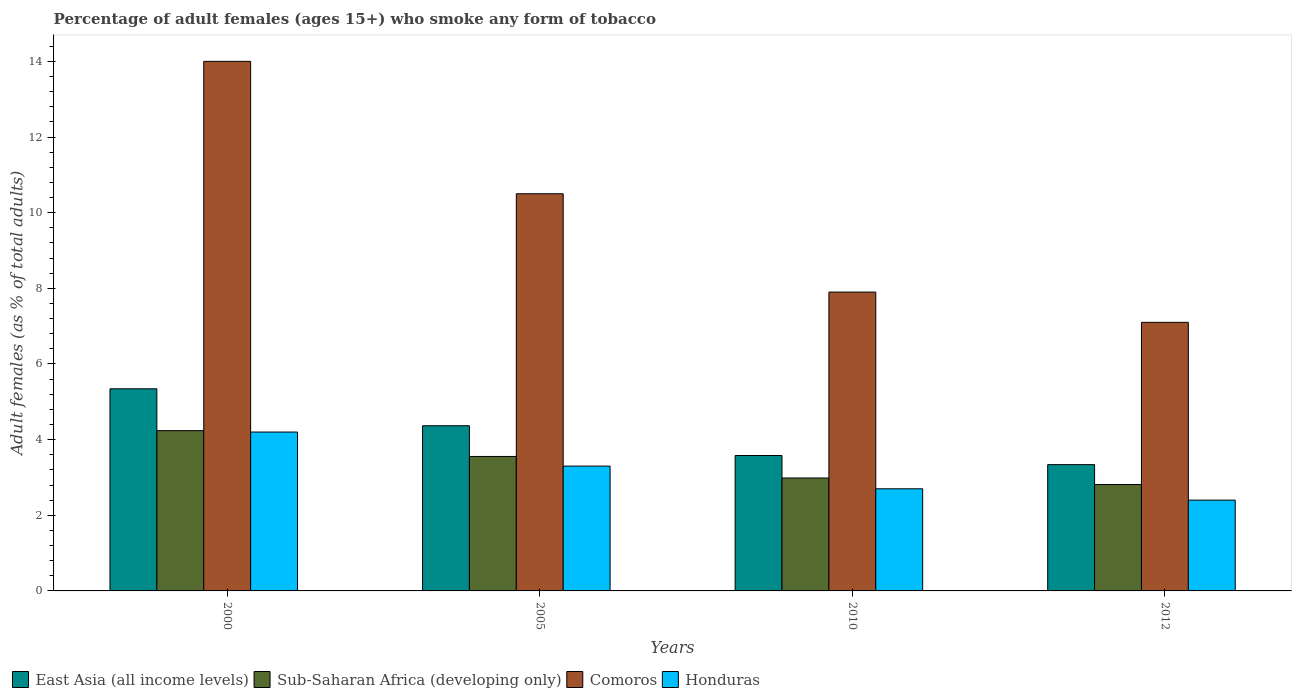How many groups of bars are there?
Your answer should be compact. 4. Are the number of bars per tick equal to the number of legend labels?
Make the answer very short. Yes. Are the number of bars on each tick of the X-axis equal?
Ensure brevity in your answer.  Yes. How many bars are there on the 3rd tick from the left?
Provide a short and direct response. 4. How many bars are there on the 3rd tick from the right?
Your answer should be very brief. 4. In how many cases, is the number of bars for a given year not equal to the number of legend labels?
Offer a terse response. 0. What is the percentage of adult females who smoke in Sub-Saharan Africa (developing only) in 2010?
Your response must be concise. 2.99. Across all years, what is the minimum percentage of adult females who smoke in Sub-Saharan Africa (developing only)?
Offer a terse response. 2.81. In which year was the percentage of adult females who smoke in East Asia (all income levels) maximum?
Provide a succinct answer. 2000. In which year was the percentage of adult females who smoke in East Asia (all income levels) minimum?
Give a very brief answer. 2012. What is the total percentage of adult females who smoke in Comoros in the graph?
Your answer should be compact. 39.5. What is the difference between the percentage of adult females who smoke in Sub-Saharan Africa (developing only) in 2000 and that in 2012?
Provide a short and direct response. 1.42. What is the difference between the percentage of adult females who smoke in Comoros in 2010 and the percentage of adult females who smoke in Honduras in 2012?
Give a very brief answer. 5.5. What is the average percentage of adult females who smoke in Sub-Saharan Africa (developing only) per year?
Offer a very short reply. 3.4. What is the ratio of the percentage of adult females who smoke in Sub-Saharan Africa (developing only) in 2005 to that in 2012?
Provide a short and direct response. 1.26. What is the difference between the highest and the second highest percentage of adult females who smoke in Sub-Saharan Africa (developing only)?
Provide a succinct answer. 0.68. What is the difference between the highest and the lowest percentage of adult females who smoke in Honduras?
Your answer should be very brief. 1.8. In how many years, is the percentage of adult females who smoke in East Asia (all income levels) greater than the average percentage of adult females who smoke in East Asia (all income levels) taken over all years?
Offer a very short reply. 2. Is it the case that in every year, the sum of the percentage of adult females who smoke in Sub-Saharan Africa (developing only) and percentage of adult females who smoke in East Asia (all income levels) is greater than the sum of percentage of adult females who smoke in Comoros and percentage of adult females who smoke in Honduras?
Your answer should be very brief. No. What does the 2nd bar from the left in 2005 represents?
Ensure brevity in your answer.  Sub-Saharan Africa (developing only). What does the 3rd bar from the right in 2012 represents?
Your answer should be compact. Sub-Saharan Africa (developing only). Is it the case that in every year, the sum of the percentage of adult females who smoke in Honduras and percentage of adult females who smoke in Sub-Saharan Africa (developing only) is greater than the percentage of adult females who smoke in Comoros?
Provide a succinct answer. No. How many bars are there?
Offer a terse response. 16. Are all the bars in the graph horizontal?
Offer a very short reply. No. What is the difference between two consecutive major ticks on the Y-axis?
Make the answer very short. 2. Where does the legend appear in the graph?
Offer a terse response. Bottom left. How many legend labels are there?
Your answer should be very brief. 4. What is the title of the graph?
Offer a very short reply. Percentage of adult females (ages 15+) who smoke any form of tobacco. What is the label or title of the Y-axis?
Your answer should be very brief. Adult females (as % of total adults). What is the Adult females (as % of total adults) of East Asia (all income levels) in 2000?
Offer a very short reply. 5.34. What is the Adult females (as % of total adults) in Sub-Saharan Africa (developing only) in 2000?
Make the answer very short. 4.24. What is the Adult females (as % of total adults) in Comoros in 2000?
Provide a short and direct response. 14. What is the Adult females (as % of total adults) in Honduras in 2000?
Ensure brevity in your answer.  4.2. What is the Adult females (as % of total adults) of East Asia (all income levels) in 2005?
Offer a terse response. 4.37. What is the Adult females (as % of total adults) of Sub-Saharan Africa (developing only) in 2005?
Your answer should be compact. 3.55. What is the Adult females (as % of total adults) of Comoros in 2005?
Offer a terse response. 10.5. What is the Adult females (as % of total adults) of East Asia (all income levels) in 2010?
Provide a short and direct response. 3.58. What is the Adult females (as % of total adults) of Sub-Saharan Africa (developing only) in 2010?
Your response must be concise. 2.99. What is the Adult females (as % of total adults) in Comoros in 2010?
Provide a short and direct response. 7.9. What is the Adult females (as % of total adults) in East Asia (all income levels) in 2012?
Offer a very short reply. 3.34. What is the Adult females (as % of total adults) in Sub-Saharan Africa (developing only) in 2012?
Ensure brevity in your answer.  2.81. Across all years, what is the maximum Adult females (as % of total adults) in East Asia (all income levels)?
Keep it short and to the point. 5.34. Across all years, what is the maximum Adult females (as % of total adults) in Sub-Saharan Africa (developing only)?
Ensure brevity in your answer.  4.24. Across all years, what is the minimum Adult females (as % of total adults) in East Asia (all income levels)?
Keep it short and to the point. 3.34. Across all years, what is the minimum Adult females (as % of total adults) in Sub-Saharan Africa (developing only)?
Offer a very short reply. 2.81. Across all years, what is the minimum Adult females (as % of total adults) of Comoros?
Offer a very short reply. 7.1. Across all years, what is the minimum Adult females (as % of total adults) in Honduras?
Make the answer very short. 2.4. What is the total Adult females (as % of total adults) of East Asia (all income levels) in the graph?
Make the answer very short. 16.63. What is the total Adult females (as % of total adults) in Sub-Saharan Africa (developing only) in the graph?
Make the answer very short. 13.59. What is the total Adult females (as % of total adults) in Comoros in the graph?
Ensure brevity in your answer.  39.5. What is the difference between the Adult females (as % of total adults) of East Asia (all income levels) in 2000 and that in 2005?
Provide a succinct answer. 0.98. What is the difference between the Adult females (as % of total adults) of Sub-Saharan Africa (developing only) in 2000 and that in 2005?
Your answer should be compact. 0.68. What is the difference between the Adult females (as % of total adults) in Comoros in 2000 and that in 2005?
Make the answer very short. 3.5. What is the difference between the Adult females (as % of total adults) in East Asia (all income levels) in 2000 and that in 2010?
Ensure brevity in your answer.  1.76. What is the difference between the Adult females (as % of total adults) in Sub-Saharan Africa (developing only) in 2000 and that in 2010?
Make the answer very short. 1.25. What is the difference between the Adult females (as % of total adults) in East Asia (all income levels) in 2000 and that in 2012?
Your answer should be compact. 2. What is the difference between the Adult females (as % of total adults) of Sub-Saharan Africa (developing only) in 2000 and that in 2012?
Your response must be concise. 1.42. What is the difference between the Adult females (as % of total adults) of Honduras in 2000 and that in 2012?
Provide a short and direct response. 1.8. What is the difference between the Adult females (as % of total adults) in East Asia (all income levels) in 2005 and that in 2010?
Provide a succinct answer. 0.79. What is the difference between the Adult females (as % of total adults) in Sub-Saharan Africa (developing only) in 2005 and that in 2010?
Keep it short and to the point. 0.57. What is the difference between the Adult females (as % of total adults) in Honduras in 2005 and that in 2010?
Give a very brief answer. 0.6. What is the difference between the Adult females (as % of total adults) in East Asia (all income levels) in 2005 and that in 2012?
Your answer should be compact. 1.03. What is the difference between the Adult females (as % of total adults) of Sub-Saharan Africa (developing only) in 2005 and that in 2012?
Offer a terse response. 0.74. What is the difference between the Adult females (as % of total adults) of East Asia (all income levels) in 2010 and that in 2012?
Your answer should be very brief. 0.24. What is the difference between the Adult females (as % of total adults) in Sub-Saharan Africa (developing only) in 2010 and that in 2012?
Give a very brief answer. 0.17. What is the difference between the Adult females (as % of total adults) of Comoros in 2010 and that in 2012?
Make the answer very short. 0.8. What is the difference between the Adult females (as % of total adults) of East Asia (all income levels) in 2000 and the Adult females (as % of total adults) of Sub-Saharan Africa (developing only) in 2005?
Your response must be concise. 1.79. What is the difference between the Adult females (as % of total adults) of East Asia (all income levels) in 2000 and the Adult females (as % of total adults) of Comoros in 2005?
Your answer should be very brief. -5.16. What is the difference between the Adult females (as % of total adults) in East Asia (all income levels) in 2000 and the Adult females (as % of total adults) in Honduras in 2005?
Your answer should be compact. 2.04. What is the difference between the Adult females (as % of total adults) in Sub-Saharan Africa (developing only) in 2000 and the Adult females (as % of total adults) in Comoros in 2005?
Provide a succinct answer. -6.26. What is the difference between the Adult females (as % of total adults) in Sub-Saharan Africa (developing only) in 2000 and the Adult females (as % of total adults) in Honduras in 2005?
Make the answer very short. 0.94. What is the difference between the Adult females (as % of total adults) of Comoros in 2000 and the Adult females (as % of total adults) of Honduras in 2005?
Make the answer very short. 10.7. What is the difference between the Adult females (as % of total adults) of East Asia (all income levels) in 2000 and the Adult females (as % of total adults) of Sub-Saharan Africa (developing only) in 2010?
Your response must be concise. 2.36. What is the difference between the Adult females (as % of total adults) of East Asia (all income levels) in 2000 and the Adult females (as % of total adults) of Comoros in 2010?
Ensure brevity in your answer.  -2.56. What is the difference between the Adult females (as % of total adults) in East Asia (all income levels) in 2000 and the Adult females (as % of total adults) in Honduras in 2010?
Make the answer very short. 2.64. What is the difference between the Adult females (as % of total adults) in Sub-Saharan Africa (developing only) in 2000 and the Adult females (as % of total adults) in Comoros in 2010?
Keep it short and to the point. -3.66. What is the difference between the Adult females (as % of total adults) in Sub-Saharan Africa (developing only) in 2000 and the Adult females (as % of total adults) in Honduras in 2010?
Give a very brief answer. 1.54. What is the difference between the Adult females (as % of total adults) of East Asia (all income levels) in 2000 and the Adult females (as % of total adults) of Sub-Saharan Africa (developing only) in 2012?
Give a very brief answer. 2.53. What is the difference between the Adult females (as % of total adults) in East Asia (all income levels) in 2000 and the Adult females (as % of total adults) in Comoros in 2012?
Your answer should be very brief. -1.76. What is the difference between the Adult females (as % of total adults) of East Asia (all income levels) in 2000 and the Adult females (as % of total adults) of Honduras in 2012?
Provide a succinct answer. 2.94. What is the difference between the Adult females (as % of total adults) in Sub-Saharan Africa (developing only) in 2000 and the Adult females (as % of total adults) in Comoros in 2012?
Your response must be concise. -2.86. What is the difference between the Adult females (as % of total adults) in Sub-Saharan Africa (developing only) in 2000 and the Adult females (as % of total adults) in Honduras in 2012?
Provide a short and direct response. 1.84. What is the difference between the Adult females (as % of total adults) of East Asia (all income levels) in 2005 and the Adult females (as % of total adults) of Sub-Saharan Africa (developing only) in 2010?
Make the answer very short. 1.38. What is the difference between the Adult females (as % of total adults) of East Asia (all income levels) in 2005 and the Adult females (as % of total adults) of Comoros in 2010?
Ensure brevity in your answer.  -3.53. What is the difference between the Adult females (as % of total adults) of East Asia (all income levels) in 2005 and the Adult females (as % of total adults) of Honduras in 2010?
Provide a succinct answer. 1.67. What is the difference between the Adult females (as % of total adults) in Sub-Saharan Africa (developing only) in 2005 and the Adult females (as % of total adults) in Comoros in 2010?
Provide a short and direct response. -4.35. What is the difference between the Adult females (as % of total adults) of Sub-Saharan Africa (developing only) in 2005 and the Adult females (as % of total adults) of Honduras in 2010?
Give a very brief answer. 0.85. What is the difference between the Adult females (as % of total adults) in Comoros in 2005 and the Adult females (as % of total adults) in Honduras in 2010?
Keep it short and to the point. 7.8. What is the difference between the Adult females (as % of total adults) in East Asia (all income levels) in 2005 and the Adult females (as % of total adults) in Sub-Saharan Africa (developing only) in 2012?
Your answer should be very brief. 1.55. What is the difference between the Adult females (as % of total adults) of East Asia (all income levels) in 2005 and the Adult females (as % of total adults) of Comoros in 2012?
Make the answer very short. -2.73. What is the difference between the Adult females (as % of total adults) in East Asia (all income levels) in 2005 and the Adult females (as % of total adults) in Honduras in 2012?
Your answer should be compact. 1.97. What is the difference between the Adult females (as % of total adults) in Sub-Saharan Africa (developing only) in 2005 and the Adult females (as % of total adults) in Comoros in 2012?
Keep it short and to the point. -3.55. What is the difference between the Adult females (as % of total adults) of Sub-Saharan Africa (developing only) in 2005 and the Adult females (as % of total adults) of Honduras in 2012?
Offer a very short reply. 1.15. What is the difference between the Adult females (as % of total adults) of Comoros in 2005 and the Adult females (as % of total adults) of Honduras in 2012?
Ensure brevity in your answer.  8.1. What is the difference between the Adult females (as % of total adults) of East Asia (all income levels) in 2010 and the Adult females (as % of total adults) of Sub-Saharan Africa (developing only) in 2012?
Provide a succinct answer. 0.77. What is the difference between the Adult females (as % of total adults) in East Asia (all income levels) in 2010 and the Adult females (as % of total adults) in Comoros in 2012?
Keep it short and to the point. -3.52. What is the difference between the Adult females (as % of total adults) of East Asia (all income levels) in 2010 and the Adult females (as % of total adults) of Honduras in 2012?
Provide a succinct answer. 1.18. What is the difference between the Adult females (as % of total adults) of Sub-Saharan Africa (developing only) in 2010 and the Adult females (as % of total adults) of Comoros in 2012?
Keep it short and to the point. -4.11. What is the difference between the Adult females (as % of total adults) in Sub-Saharan Africa (developing only) in 2010 and the Adult females (as % of total adults) in Honduras in 2012?
Offer a terse response. 0.59. What is the difference between the Adult females (as % of total adults) in Comoros in 2010 and the Adult females (as % of total adults) in Honduras in 2012?
Your response must be concise. 5.5. What is the average Adult females (as % of total adults) of East Asia (all income levels) per year?
Ensure brevity in your answer.  4.16. What is the average Adult females (as % of total adults) in Sub-Saharan Africa (developing only) per year?
Your response must be concise. 3.4. What is the average Adult females (as % of total adults) of Comoros per year?
Your answer should be compact. 9.88. What is the average Adult females (as % of total adults) of Honduras per year?
Give a very brief answer. 3.15. In the year 2000, what is the difference between the Adult females (as % of total adults) in East Asia (all income levels) and Adult females (as % of total adults) in Sub-Saharan Africa (developing only)?
Give a very brief answer. 1.11. In the year 2000, what is the difference between the Adult females (as % of total adults) of East Asia (all income levels) and Adult females (as % of total adults) of Comoros?
Give a very brief answer. -8.66. In the year 2000, what is the difference between the Adult females (as % of total adults) of East Asia (all income levels) and Adult females (as % of total adults) of Honduras?
Your answer should be very brief. 1.14. In the year 2000, what is the difference between the Adult females (as % of total adults) of Sub-Saharan Africa (developing only) and Adult females (as % of total adults) of Comoros?
Offer a very short reply. -9.76. In the year 2000, what is the difference between the Adult females (as % of total adults) in Sub-Saharan Africa (developing only) and Adult females (as % of total adults) in Honduras?
Provide a succinct answer. 0.04. In the year 2000, what is the difference between the Adult females (as % of total adults) in Comoros and Adult females (as % of total adults) in Honduras?
Make the answer very short. 9.8. In the year 2005, what is the difference between the Adult females (as % of total adults) of East Asia (all income levels) and Adult females (as % of total adults) of Sub-Saharan Africa (developing only)?
Provide a short and direct response. 0.81. In the year 2005, what is the difference between the Adult females (as % of total adults) in East Asia (all income levels) and Adult females (as % of total adults) in Comoros?
Provide a succinct answer. -6.13. In the year 2005, what is the difference between the Adult females (as % of total adults) of East Asia (all income levels) and Adult females (as % of total adults) of Honduras?
Ensure brevity in your answer.  1.07. In the year 2005, what is the difference between the Adult females (as % of total adults) in Sub-Saharan Africa (developing only) and Adult females (as % of total adults) in Comoros?
Ensure brevity in your answer.  -6.95. In the year 2005, what is the difference between the Adult females (as % of total adults) in Sub-Saharan Africa (developing only) and Adult females (as % of total adults) in Honduras?
Your answer should be compact. 0.25. In the year 2010, what is the difference between the Adult females (as % of total adults) in East Asia (all income levels) and Adult females (as % of total adults) in Sub-Saharan Africa (developing only)?
Your response must be concise. 0.6. In the year 2010, what is the difference between the Adult females (as % of total adults) in East Asia (all income levels) and Adult females (as % of total adults) in Comoros?
Offer a terse response. -4.32. In the year 2010, what is the difference between the Adult females (as % of total adults) of East Asia (all income levels) and Adult females (as % of total adults) of Honduras?
Make the answer very short. 0.88. In the year 2010, what is the difference between the Adult females (as % of total adults) of Sub-Saharan Africa (developing only) and Adult females (as % of total adults) of Comoros?
Provide a succinct answer. -4.91. In the year 2010, what is the difference between the Adult females (as % of total adults) in Sub-Saharan Africa (developing only) and Adult females (as % of total adults) in Honduras?
Your answer should be compact. 0.29. In the year 2012, what is the difference between the Adult females (as % of total adults) of East Asia (all income levels) and Adult females (as % of total adults) of Sub-Saharan Africa (developing only)?
Provide a short and direct response. 0.53. In the year 2012, what is the difference between the Adult females (as % of total adults) of East Asia (all income levels) and Adult females (as % of total adults) of Comoros?
Give a very brief answer. -3.76. In the year 2012, what is the difference between the Adult females (as % of total adults) in East Asia (all income levels) and Adult females (as % of total adults) in Honduras?
Offer a terse response. 0.94. In the year 2012, what is the difference between the Adult females (as % of total adults) in Sub-Saharan Africa (developing only) and Adult females (as % of total adults) in Comoros?
Offer a very short reply. -4.29. In the year 2012, what is the difference between the Adult females (as % of total adults) in Sub-Saharan Africa (developing only) and Adult females (as % of total adults) in Honduras?
Provide a short and direct response. 0.41. What is the ratio of the Adult females (as % of total adults) of East Asia (all income levels) in 2000 to that in 2005?
Offer a terse response. 1.22. What is the ratio of the Adult females (as % of total adults) of Sub-Saharan Africa (developing only) in 2000 to that in 2005?
Ensure brevity in your answer.  1.19. What is the ratio of the Adult females (as % of total adults) of Comoros in 2000 to that in 2005?
Your answer should be compact. 1.33. What is the ratio of the Adult females (as % of total adults) in Honduras in 2000 to that in 2005?
Keep it short and to the point. 1.27. What is the ratio of the Adult females (as % of total adults) of East Asia (all income levels) in 2000 to that in 2010?
Make the answer very short. 1.49. What is the ratio of the Adult females (as % of total adults) in Sub-Saharan Africa (developing only) in 2000 to that in 2010?
Keep it short and to the point. 1.42. What is the ratio of the Adult females (as % of total adults) in Comoros in 2000 to that in 2010?
Provide a short and direct response. 1.77. What is the ratio of the Adult females (as % of total adults) in Honduras in 2000 to that in 2010?
Provide a short and direct response. 1.56. What is the ratio of the Adult females (as % of total adults) in East Asia (all income levels) in 2000 to that in 2012?
Provide a succinct answer. 1.6. What is the ratio of the Adult females (as % of total adults) in Sub-Saharan Africa (developing only) in 2000 to that in 2012?
Your response must be concise. 1.51. What is the ratio of the Adult females (as % of total adults) in Comoros in 2000 to that in 2012?
Your answer should be compact. 1.97. What is the ratio of the Adult females (as % of total adults) in East Asia (all income levels) in 2005 to that in 2010?
Make the answer very short. 1.22. What is the ratio of the Adult females (as % of total adults) of Sub-Saharan Africa (developing only) in 2005 to that in 2010?
Offer a terse response. 1.19. What is the ratio of the Adult females (as % of total adults) of Comoros in 2005 to that in 2010?
Keep it short and to the point. 1.33. What is the ratio of the Adult females (as % of total adults) in Honduras in 2005 to that in 2010?
Keep it short and to the point. 1.22. What is the ratio of the Adult females (as % of total adults) in East Asia (all income levels) in 2005 to that in 2012?
Ensure brevity in your answer.  1.31. What is the ratio of the Adult females (as % of total adults) in Sub-Saharan Africa (developing only) in 2005 to that in 2012?
Your response must be concise. 1.26. What is the ratio of the Adult females (as % of total adults) of Comoros in 2005 to that in 2012?
Make the answer very short. 1.48. What is the ratio of the Adult females (as % of total adults) in Honduras in 2005 to that in 2012?
Keep it short and to the point. 1.38. What is the ratio of the Adult females (as % of total adults) in East Asia (all income levels) in 2010 to that in 2012?
Provide a short and direct response. 1.07. What is the ratio of the Adult females (as % of total adults) in Sub-Saharan Africa (developing only) in 2010 to that in 2012?
Make the answer very short. 1.06. What is the ratio of the Adult females (as % of total adults) in Comoros in 2010 to that in 2012?
Make the answer very short. 1.11. What is the difference between the highest and the second highest Adult females (as % of total adults) of East Asia (all income levels)?
Offer a terse response. 0.98. What is the difference between the highest and the second highest Adult females (as % of total adults) of Sub-Saharan Africa (developing only)?
Offer a terse response. 0.68. What is the difference between the highest and the second highest Adult females (as % of total adults) in Comoros?
Offer a very short reply. 3.5. What is the difference between the highest and the lowest Adult females (as % of total adults) of East Asia (all income levels)?
Keep it short and to the point. 2. What is the difference between the highest and the lowest Adult females (as % of total adults) in Sub-Saharan Africa (developing only)?
Give a very brief answer. 1.42. What is the difference between the highest and the lowest Adult females (as % of total adults) in Comoros?
Your answer should be very brief. 6.9. 